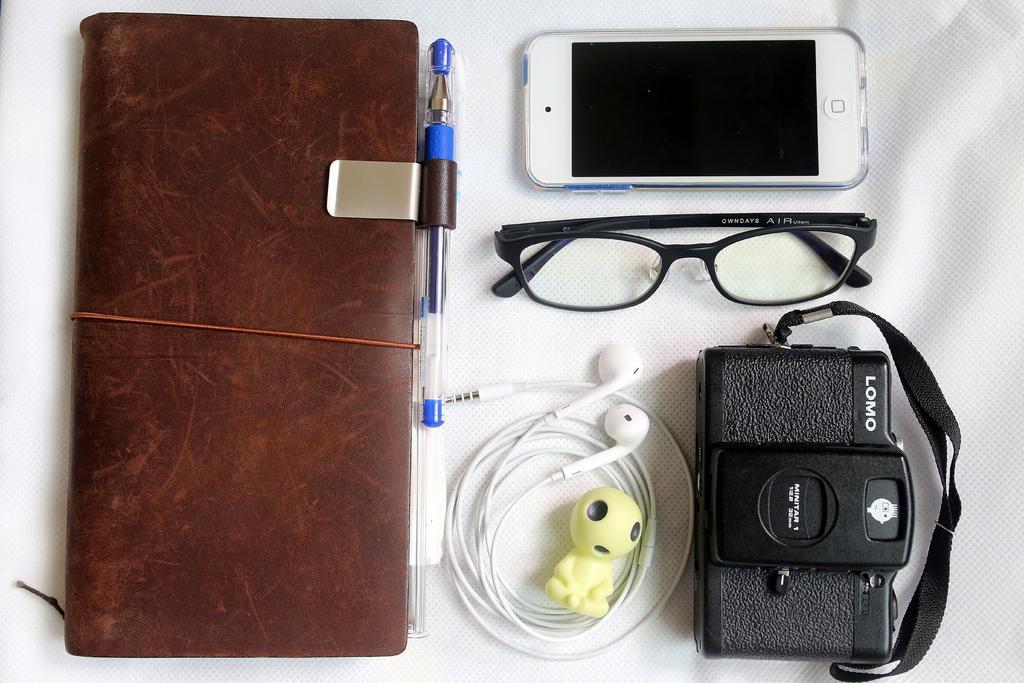Can you describe this image briefly? In this image I can see a book, a pen, a mobile, a camera and other objects. These objects are on a white color surface. 